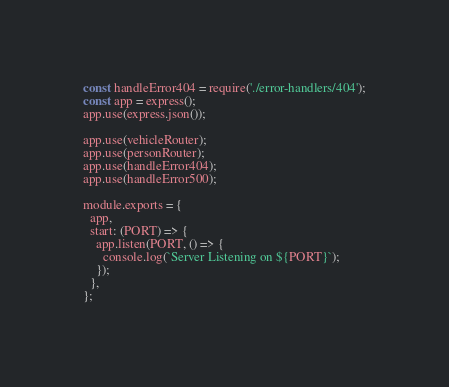<code> <loc_0><loc_0><loc_500><loc_500><_JavaScript_>const handleError404 = require('./error-handlers/404');
const app = express();
app.use(express.json());

app.use(vehicleRouter);
app.use(personRouter);
app.use(handleError404);
app.use(handleError500);

module.exports = {
  app,
  start: (PORT) => {
    app.listen(PORT, () => {
      console.log(`Server Listening on ${PORT}`);
    });
  },
};   
</code> 